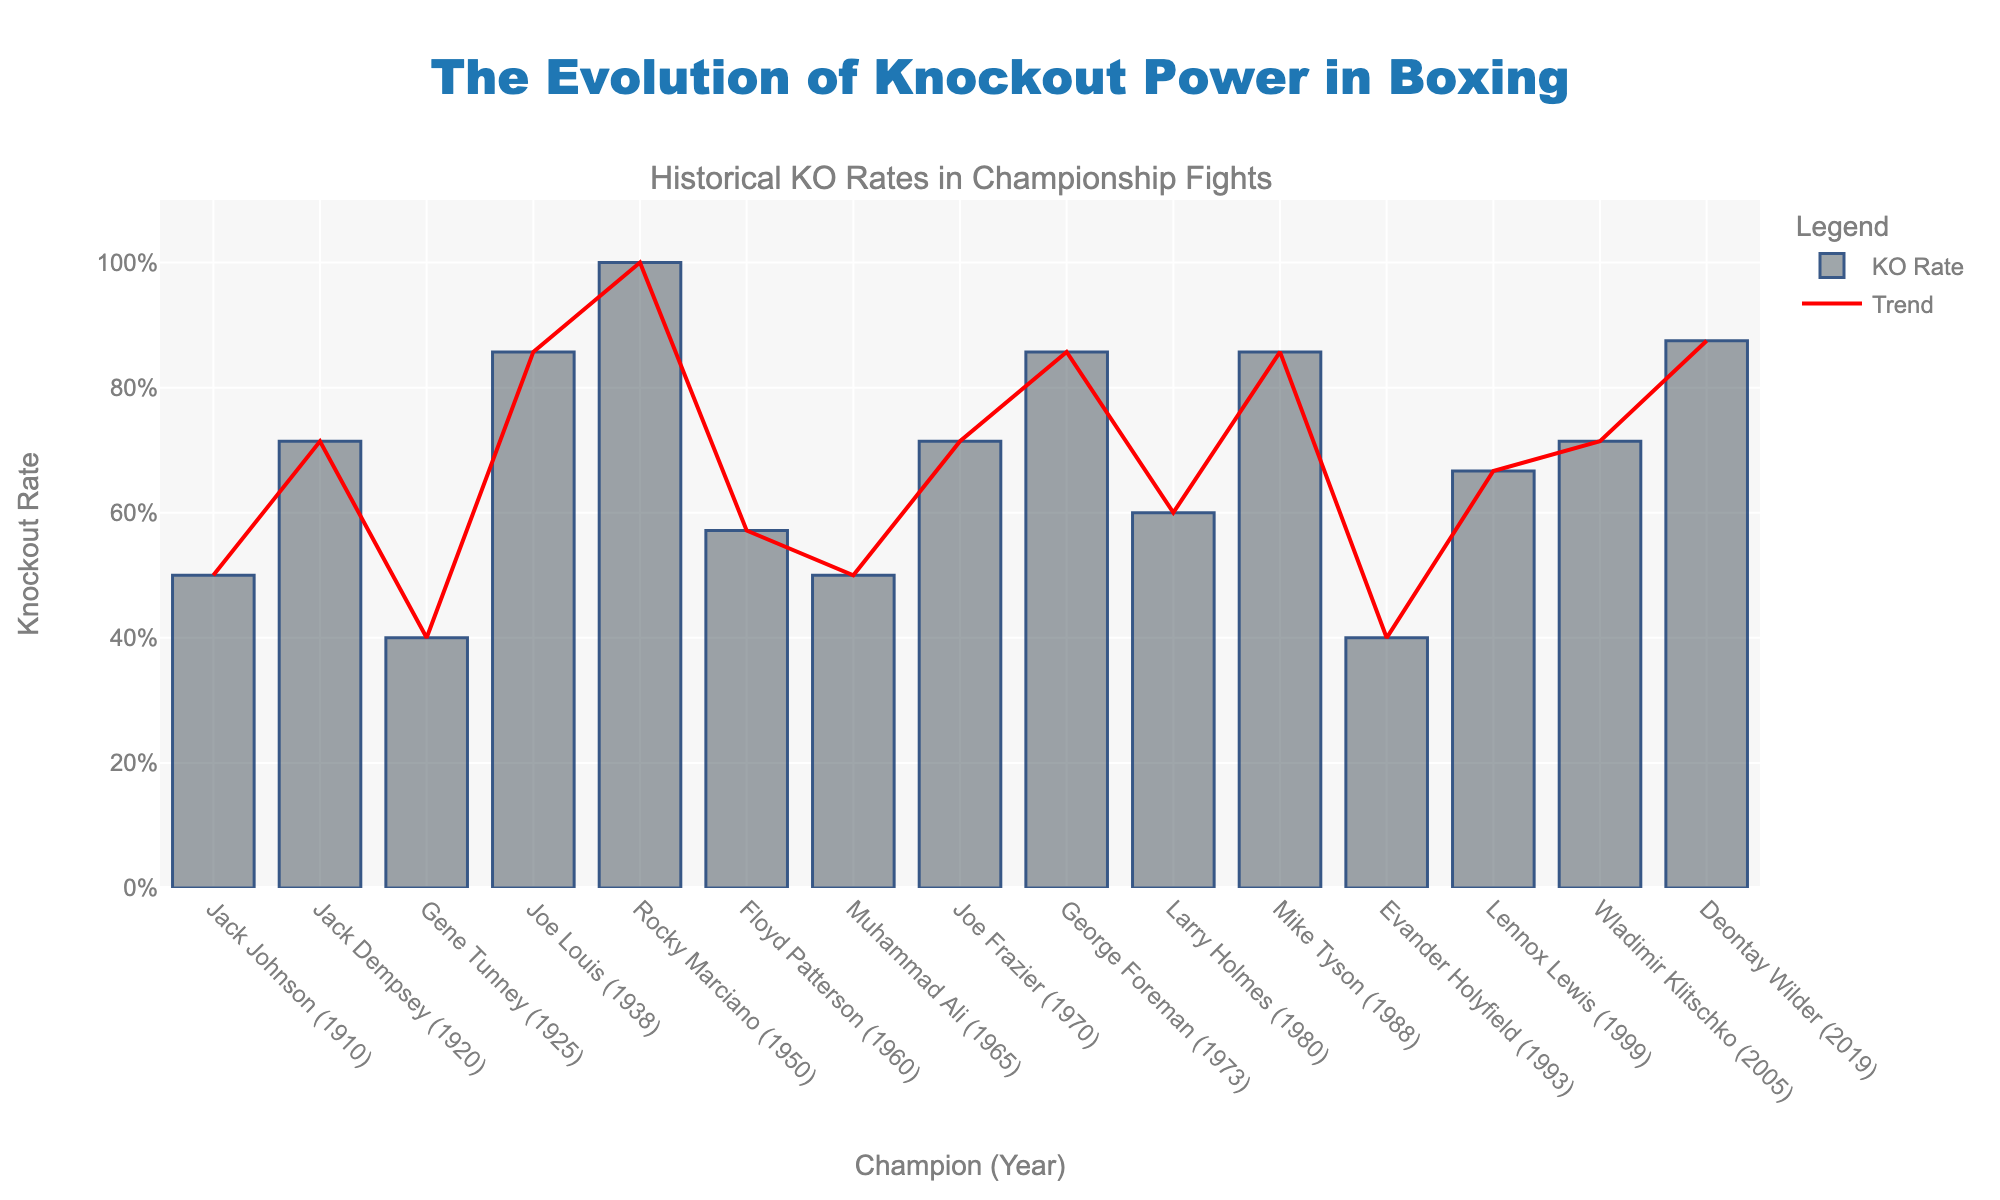What is the title of the figure? The title is located at the top in a larger, bold font, enabling viewers to quickly understand the context of the visualized data.
Answer: The Evolution of Knockout Power in Boxing Who has the highest knockout rate in the figure? Identify the bar that reaches the highest point on the y-axis, which represents the knockout rate.
Answer: Deontay Wilder Which champion has the lowest knockout rate, and what is it? Identify the bar that reaches the lowest point on the y-axis and check its corresponding champion on the x-axis. The y-axis value indicates the knockout rate.
Answer: Evander Holyfield, 40% How many champions have a knockout rate greater than 80%? Count the number of bars that surpass the 80% mark on the y-axis.
Answer: 3 What is the average knockout rate of all the champions? Sum all the individual knockout rates and divide by the number of champions. The knockout rates are: 0.5, 0.71, 0.4, 0.86, 1.0, 0.57, 0.5, 0.71, 0.86, 0.6, 0.86, 0.4, 0.67, 0.71, 0.88. Adding these gives 10.73. Divide by 15 (the number of champions): 10.73 / 15 ≈ 0.7153 or 71.53%.
Answer: 71.53% Between which years does the trend line show the most significant increase in knockout rates? Observe the red trend line and locate where it has the steepest upward slope.
Answer: 1993 to 2019 Is there any champion with an exactly 50% knockout rate? Look for the bars that align precisely with the 50% mark on the y-axis.
Answer: Yes, Jack Johnson and Muhammad Ali What is the knockout rate of Mike Tyson's championship fights? Find Mike Tyson on the x-axis and trace his bar to the y-axis to read the knockout rate.
Answer: 86% How does the knockout rate of George Foreman compare to that of Rocky Marciano? Identify both bars on the x-axis and compare their heights on the y-axis.
Answer: Both have the same knockout rate of 86% What trend can be observed about the knockout rates over the decades? Analyze the overall direction and pattern of the red trend line over the years on the x-axis.
Answer: The knockout rate shows an increasing trend over the decades 